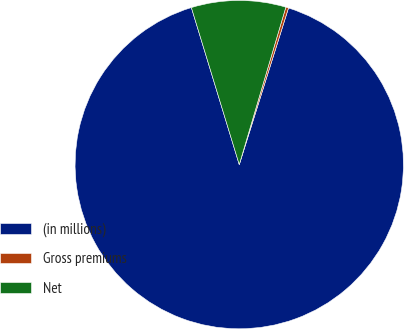Convert chart. <chart><loc_0><loc_0><loc_500><loc_500><pie_chart><fcel>(in millions)<fcel>Gross premiums<fcel>Net<nl><fcel>90.44%<fcel>0.27%<fcel>9.29%<nl></chart> 